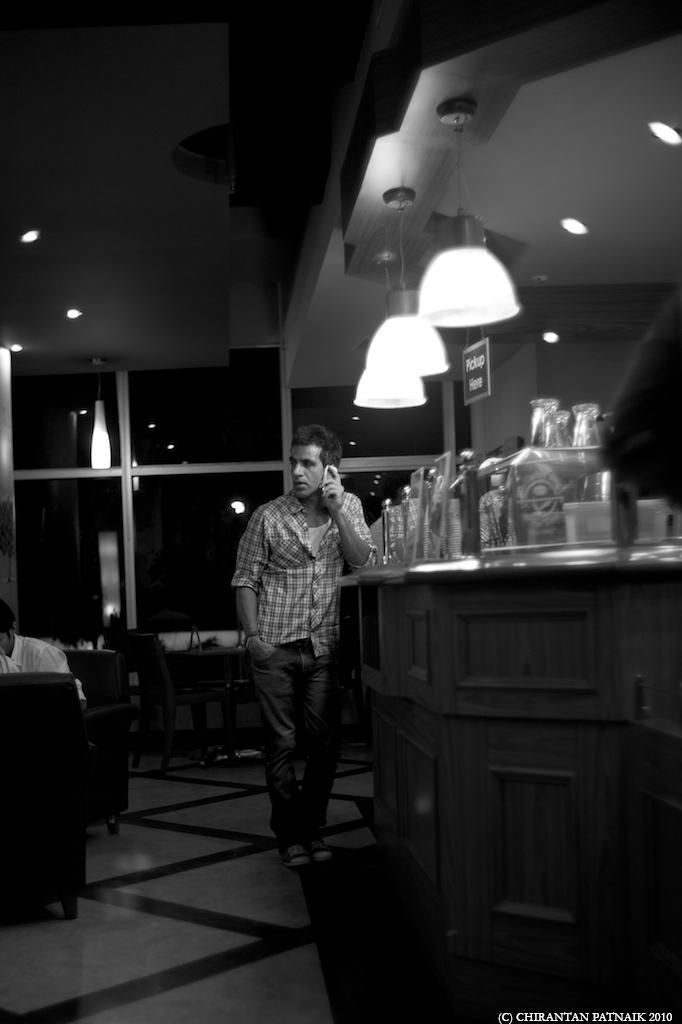Can you describe this image briefly? In the center of the image we can see a man standing. On the right there is a table and we can see glasses and bottles placed on the table. On the left there are chairs and we can see a man sitting on the chair. At the top there are lights. 